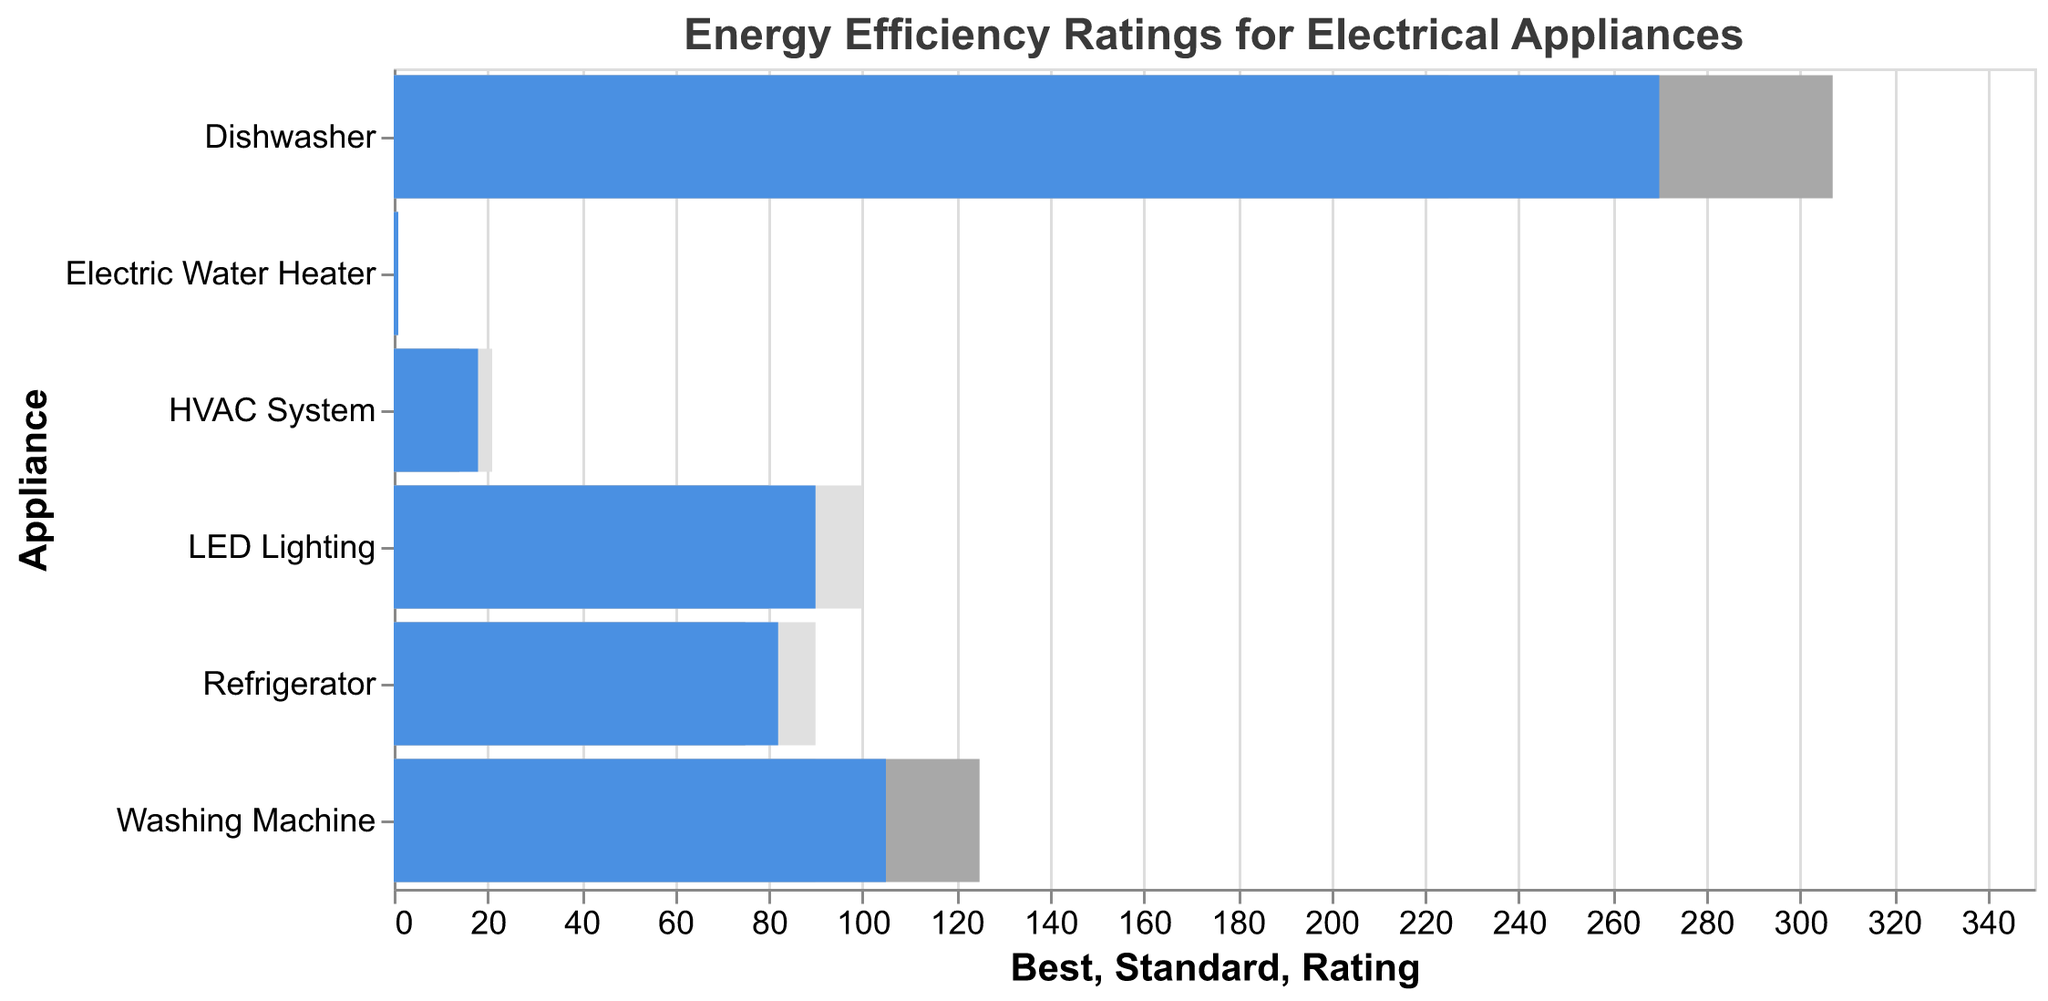What is the title of the chart? The title is usually displayed at the top of the chart and helps provide context for the data being visualized. The title here is "Energy Efficiency Ratings for Electrical Appliances".
Answer: Energy Efficiency Ratings for Electrical Appliances What does the grey bar represent for each appliance? The grey bar in a bullet chart typically represents the "Best in Class" benchmark, showing the highest standard or ideal performance benchmark for energy efficiency for each appliance.
Answer: Best in Class What is the energy efficiency rating of the Refrigerator? The energy efficiency rating of the Refrigerator is depicted by the blue bar that extends to the value 82.
Answer: 82 How does the energy efficiency rating of the HVAC System compare to the industry standard? The blue bar for the HVAC System represents its rating (18 SEER), while the dark grey bar illustrates the industry standard (14 SEER). By comparing these two bars, we see that the HVAC System's rating is higher than the industry standard.
Answer: Higher Which appliance has the closest energy efficiency rating to its "Best in Class" value? To determine this, we compare the length of the blue bars with their corresponding "Best in Class" values. The Refrigerator, with a rating of 82, is relatively close to its "Best in Class" value of 90.
Answer: Refrigerator For which appliance is the industry standard higher than its current energy efficiency rating? By comparing the dark grey bars (industry standards) and the blue bars (ratings) across all appliances, the Dishwasher's industry standard (307 kWh/year) is higher than its current rating (270 kWh/year).
Answer: Dishwasher What is the difference between the energy efficiency rating and the "Best in Class" value for LED Lighting? The rating for LED Lighting is 90 lm/W, and the "Best in Class" value is 100 lm/W. The difference is 100 - 90 = 10 lm/W.
Answer: 10 lm/W Which appliance shows the least improvement needed to reach its "Best in Class" rating? By examining the difference between the blue bar (rating) and grey bar (Best in Class value) for each appliance, the Electric Water Heater requires the least improvement. It has a rating of 0.95 UEF and a "Best in Class" value of 0.97 UEF, needing an improvement of just 0.02 UEF.
Answer: Electric Water Heater Among the listed appliances, which one has the lowest energy efficiency rating compared to the industry standards? By comparing the blue and dark grey bars for each appliance, the HVAC System has the lowest efficiency rating at 18 SEER compared to the industry standard of 14 SEER.
Answer: HVAC System 